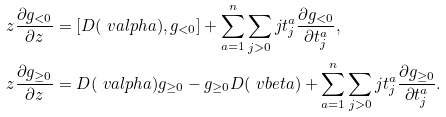Convert formula to latex. <formula><loc_0><loc_0><loc_500><loc_500>& z \frac { \partial g _ { < 0 } } { \partial z } = [ D ( \ v a l p h a ) , g _ { < 0 } ] + \sum _ { a = 1 } ^ { n } \sum _ { j > 0 } j t _ { j } ^ { a } \frac { \partial g _ { < 0 } } { \partial t _ { j } ^ { a } } , \\ & z \frac { \partial g _ { \geq 0 } } { \partial z } = D ( \ v a l p h a ) g _ { \geq 0 } - g _ { \geq 0 } D ( \ v b e t a ) + \sum _ { a = 1 } ^ { n } \sum _ { j > 0 } j t _ { j } ^ { a } \frac { \partial g _ { \geq 0 } } { \partial t _ { j } ^ { a } } .</formula> 